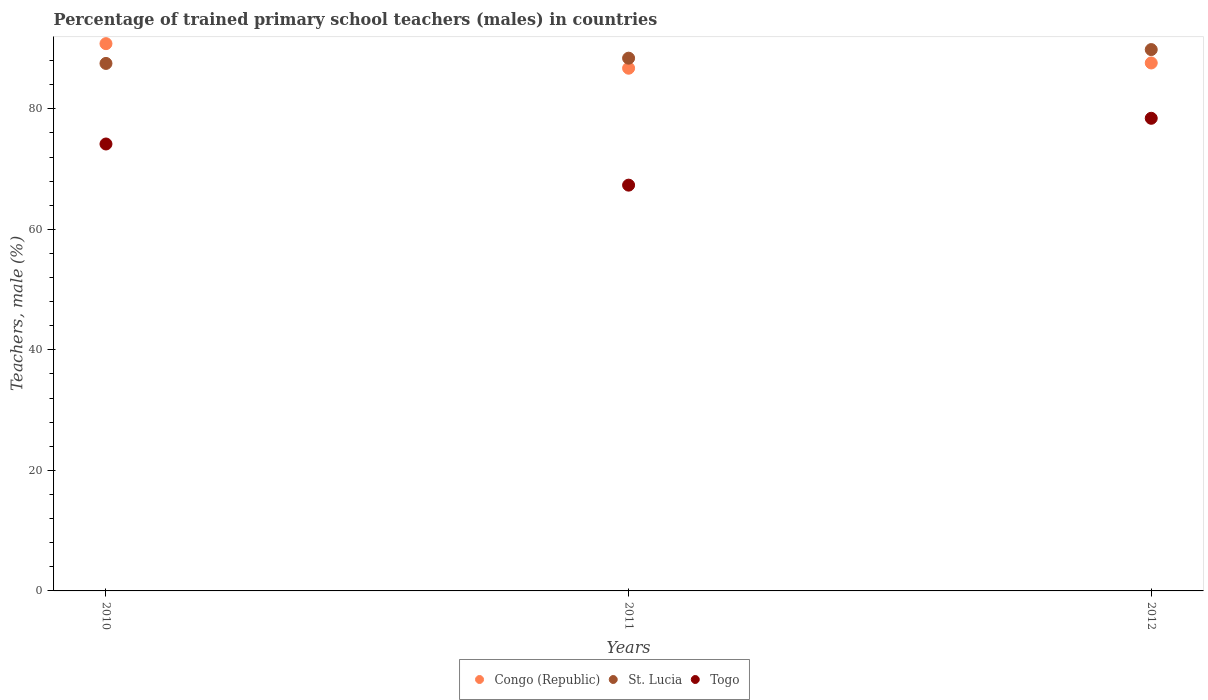How many different coloured dotlines are there?
Your answer should be compact. 3. Is the number of dotlines equal to the number of legend labels?
Your response must be concise. Yes. What is the percentage of trained primary school teachers (males) in Congo (Republic) in 2012?
Make the answer very short. 87.61. Across all years, what is the maximum percentage of trained primary school teachers (males) in St. Lucia?
Give a very brief answer. 89.82. Across all years, what is the minimum percentage of trained primary school teachers (males) in St. Lucia?
Your answer should be very brief. 87.53. In which year was the percentage of trained primary school teachers (males) in Congo (Republic) minimum?
Provide a succinct answer. 2011. What is the total percentage of trained primary school teachers (males) in St. Lucia in the graph?
Your answer should be very brief. 265.75. What is the difference between the percentage of trained primary school teachers (males) in St. Lucia in 2011 and that in 2012?
Give a very brief answer. -1.43. What is the difference between the percentage of trained primary school teachers (males) in Congo (Republic) in 2012 and the percentage of trained primary school teachers (males) in Togo in 2010?
Provide a short and direct response. 13.45. What is the average percentage of trained primary school teachers (males) in Togo per year?
Provide a succinct answer. 73.31. In the year 2010, what is the difference between the percentage of trained primary school teachers (males) in Togo and percentage of trained primary school teachers (males) in Congo (Republic)?
Keep it short and to the point. -16.65. What is the ratio of the percentage of trained primary school teachers (males) in Togo in 2010 to that in 2012?
Your answer should be compact. 0.95. What is the difference between the highest and the second highest percentage of trained primary school teachers (males) in St. Lucia?
Provide a succinct answer. 1.43. What is the difference between the highest and the lowest percentage of trained primary school teachers (males) in Congo (Republic)?
Offer a terse response. 4.08. Is it the case that in every year, the sum of the percentage of trained primary school teachers (males) in Togo and percentage of trained primary school teachers (males) in St. Lucia  is greater than the percentage of trained primary school teachers (males) in Congo (Republic)?
Your answer should be compact. Yes. Is the percentage of trained primary school teachers (males) in Togo strictly greater than the percentage of trained primary school teachers (males) in Congo (Republic) over the years?
Give a very brief answer. No. Is the percentage of trained primary school teachers (males) in Togo strictly less than the percentage of trained primary school teachers (males) in St. Lucia over the years?
Offer a terse response. Yes. How many dotlines are there?
Keep it short and to the point. 3. How many years are there in the graph?
Keep it short and to the point. 3. What is the difference between two consecutive major ticks on the Y-axis?
Your answer should be very brief. 20. Does the graph contain any zero values?
Keep it short and to the point. No. Where does the legend appear in the graph?
Keep it short and to the point. Bottom center. How many legend labels are there?
Make the answer very short. 3. What is the title of the graph?
Offer a terse response. Percentage of trained primary school teachers (males) in countries. What is the label or title of the Y-axis?
Your answer should be very brief. Teachers, male (%). What is the Teachers, male (%) of Congo (Republic) in 2010?
Your response must be concise. 90.81. What is the Teachers, male (%) in St. Lucia in 2010?
Your answer should be very brief. 87.53. What is the Teachers, male (%) in Togo in 2010?
Your response must be concise. 74.16. What is the Teachers, male (%) of Congo (Republic) in 2011?
Provide a short and direct response. 86.73. What is the Teachers, male (%) in St. Lucia in 2011?
Give a very brief answer. 88.4. What is the Teachers, male (%) of Togo in 2011?
Your answer should be very brief. 67.33. What is the Teachers, male (%) of Congo (Republic) in 2012?
Offer a terse response. 87.61. What is the Teachers, male (%) of St. Lucia in 2012?
Offer a terse response. 89.82. What is the Teachers, male (%) in Togo in 2012?
Make the answer very short. 78.42. Across all years, what is the maximum Teachers, male (%) in Congo (Republic)?
Your answer should be very brief. 90.81. Across all years, what is the maximum Teachers, male (%) of St. Lucia?
Provide a succinct answer. 89.82. Across all years, what is the maximum Teachers, male (%) in Togo?
Offer a very short reply. 78.42. Across all years, what is the minimum Teachers, male (%) of Congo (Republic)?
Keep it short and to the point. 86.73. Across all years, what is the minimum Teachers, male (%) of St. Lucia?
Keep it short and to the point. 87.53. Across all years, what is the minimum Teachers, male (%) in Togo?
Your answer should be very brief. 67.33. What is the total Teachers, male (%) in Congo (Republic) in the graph?
Offer a terse response. 265.15. What is the total Teachers, male (%) in St. Lucia in the graph?
Make the answer very short. 265.75. What is the total Teachers, male (%) in Togo in the graph?
Ensure brevity in your answer.  219.92. What is the difference between the Teachers, male (%) of Congo (Republic) in 2010 and that in 2011?
Keep it short and to the point. 4.08. What is the difference between the Teachers, male (%) of St. Lucia in 2010 and that in 2011?
Make the answer very short. -0.87. What is the difference between the Teachers, male (%) of Togo in 2010 and that in 2011?
Your answer should be compact. 6.83. What is the difference between the Teachers, male (%) in Congo (Republic) in 2010 and that in 2012?
Your response must be concise. 3.2. What is the difference between the Teachers, male (%) of St. Lucia in 2010 and that in 2012?
Your answer should be compact. -2.3. What is the difference between the Teachers, male (%) in Togo in 2010 and that in 2012?
Provide a short and direct response. -4.26. What is the difference between the Teachers, male (%) of Congo (Republic) in 2011 and that in 2012?
Give a very brief answer. -0.87. What is the difference between the Teachers, male (%) of St. Lucia in 2011 and that in 2012?
Give a very brief answer. -1.43. What is the difference between the Teachers, male (%) of Togo in 2011 and that in 2012?
Make the answer very short. -11.09. What is the difference between the Teachers, male (%) in Congo (Republic) in 2010 and the Teachers, male (%) in St. Lucia in 2011?
Ensure brevity in your answer.  2.41. What is the difference between the Teachers, male (%) in Congo (Republic) in 2010 and the Teachers, male (%) in Togo in 2011?
Offer a terse response. 23.48. What is the difference between the Teachers, male (%) in St. Lucia in 2010 and the Teachers, male (%) in Togo in 2011?
Provide a short and direct response. 20.2. What is the difference between the Teachers, male (%) of Congo (Republic) in 2010 and the Teachers, male (%) of St. Lucia in 2012?
Provide a short and direct response. 0.98. What is the difference between the Teachers, male (%) in Congo (Republic) in 2010 and the Teachers, male (%) in Togo in 2012?
Provide a succinct answer. 12.39. What is the difference between the Teachers, male (%) in St. Lucia in 2010 and the Teachers, male (%) in Togo in 2012?
Provide a succinct answer. 9.1. What is the difference between the Teachers, male (%) in Congo (Republic) in 2011 and the Teachers, male (%) in St. Lucia in 2012?
Provide a short and direct response. -3.09. What is the difference between the Teachers, male (%) in Congo (Republic) in 2011 and the Teachers, male (%) in Togo in 2012?
Ensure brevity in your answer.  8.31. What is the difference between the Teachers, male (%) in St. Lucia in 2011 and the Teachers, male (%) in Togo in 2012?
Your answer should be compact. 9.98. What is the average Teachers, male (%) of Congo (Republic) per year?
Offer a very short reply. 88.38. What is the average Teachers, male (%) of St. Lucia per year?
Your answer should be compact. 88.58. What is the average Teachers, male (%) in Togo per year?
Your answer should be compact. 73.31. In the year 2010, what is the difference between the Teachers, male (%) of Congo (Republic) and Teachers, male (%) of St. Lucia?
Provide a succinct answer. 3.28. In the year 2010, what is the difference between the Teachers, male (%) of Congo (Republic) and Teachers, male (%) of Togo?
Offer a very short reply. 16.65. In the year 2010, what is the difference between the Teachers, male (%) of St. Lucia and Teachers, male (%) of Togo?
Provide a short and direct response. 13.37. In the year 2011, what is the difference between the Teachers, male (%) in Congo (Republic) and Teachers, male (%) in St. Lucia?
Provide a succinct answer. -1.67. In the year 2011, what is the difference between the Teachers, male (%) in Congo (Republic) and Teachers, male (%) in Togo?
Your response must be concise. 19.4. In the year 2011, what is the difference between the Teachers, male (%) of St. Lucia and Teachers, male (%) of Togo?
Provide a short and direct response. 21.07. In the year 2012, what is the difference between the Teachers, male (%) in Congo (Republic) and Teachers, male (%) in St. Lucia?
Ensure brevity in your answer.  -2.22. In the year 2012, what is the difference between the Teachers, male (%) of Congo (Republic) and Teachers, male (%) of Togo?
Ensure brevity in your answer.  9.18. In the year 2012, what is the difference between the Teachers, male (%) of St. Lucia and Teachers, male (%) of Togo?
Make the answer very short. 11.4. What is the ratio of the Teachers, male (%) in Congo (Republic) in 2010 to that in 2011?
Your answer should be very brief. 1.05. What is the ratio of the Teachers, male (%) of St. Lucia in 2010 to that in 2011?
Provide a short and direct response. 0.99. What is the ratio of the Teachers, male (%) in Togo in 2010 to that in 2011?
Ensure brevity in your answer.  1.1. What is the ratio of the Teachers, male (%) of Congo (Republic) in 2010 to that in 2012?
Provide a succinct answer. 1.04. What is the ratio of the Teachers, male (%) of St. Lucia in 2010 to that in 2012?
Offer a terse response. 0.97. What is the ratio of the Teachers, male (%) in Togo in 2010 to that in 2012?
Your response must be concise. 0.95. What is the ratio of the Teachers, male (%) of Congo (Republic) in 2011 to that in 2012?
Provide a succinct answer. 0.99. What is the ratio of the Teachers, male (%) of St. Lucia in 2011 to that in 2012?
Offer a very short reply. 0.98. What is the ratio of the Teachers, male (%) in Togo in 2011 to that in 2012?
Keep it short and to the point. 0.86. What is the difference between the highest and the second highest Teachers, male (%) of Congo (Republic)?
Ensure brevity in your answer.  3.2. What is the difference between the highest and the second highest Teachers, male (%) in St. Lucia?
Your answer should be compact. 1.43. What is the difference between the highest and the second highest Teachers, male (%) in Togo?
Keep it short and to the point. 4.26. What is the difference between the highest and the lowest Teachers, male (%) in Congo (Republic)?
Your response must be concise. 4.08. What is the difference between the highest and the lowest Teachers, male (%) of St. Lucia?
Your response must be concise. 2.3. What is the difference between the highest and the lowest Teachers, male (%) of Togo?
Give a very brief answer. 11.09. 